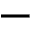Convert formula to latex. <formula><loc_0><loc_0><loc_500><loc_500>-</formula> 